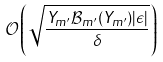<formula> <loc_0><loc_0><loc_500><loc_500>\mathcal { O } \left ( \sqrt { \frac { Y _ { m ^ { \prime } } \mathcal { B } _ { m ^ { \prime } } ( Y _ { m ^ { \prime } } ) | \epsilon | } { \delta } } \right )</formula> 